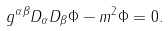<formula> <loc_0><loc_0><loc_500><loc_500>g ^ { \alpha \beta } D _ { \alpha } D _ { \beta } \Phi - { m ^ { 2 } } \Phi = 0 .</formula> 